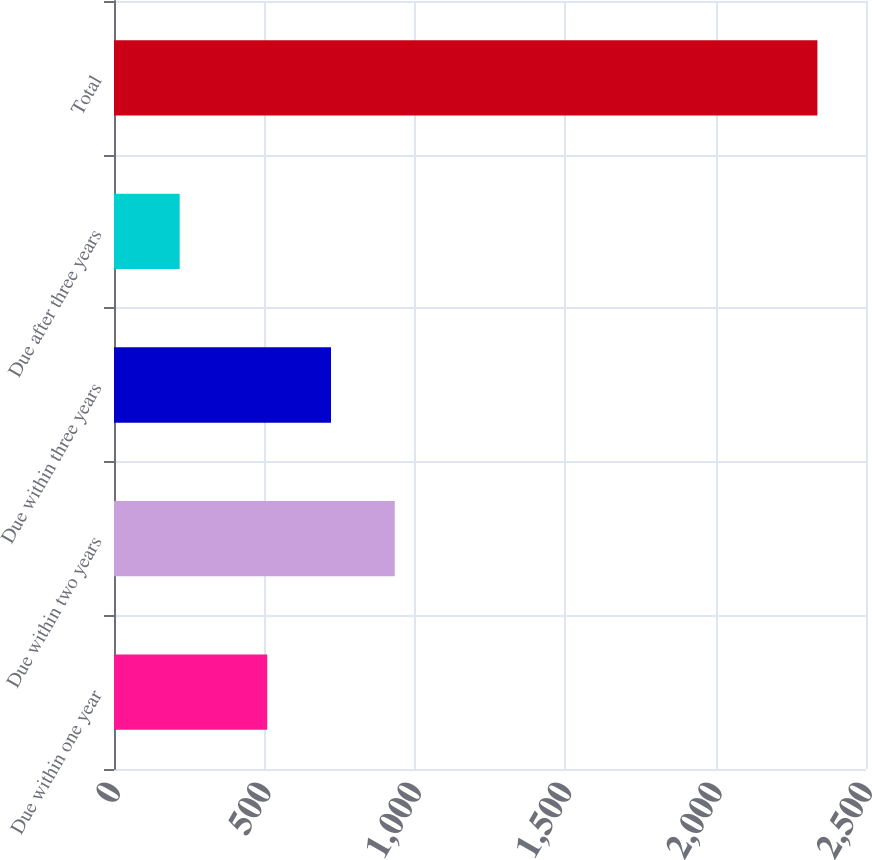Convert chart to OTSL. <chart><loc_0><loc_0><loc_500><loc_500><bar_chart><fcel>Due within one year<fcel>Due within two years<fcel>Due within three years<fcel>Due after three years<fcel>Total<nl><fcel>509.4<fcel>933.44<fcel>721.42<fcel>218.3<fcel>2338.5<nl></chart> 